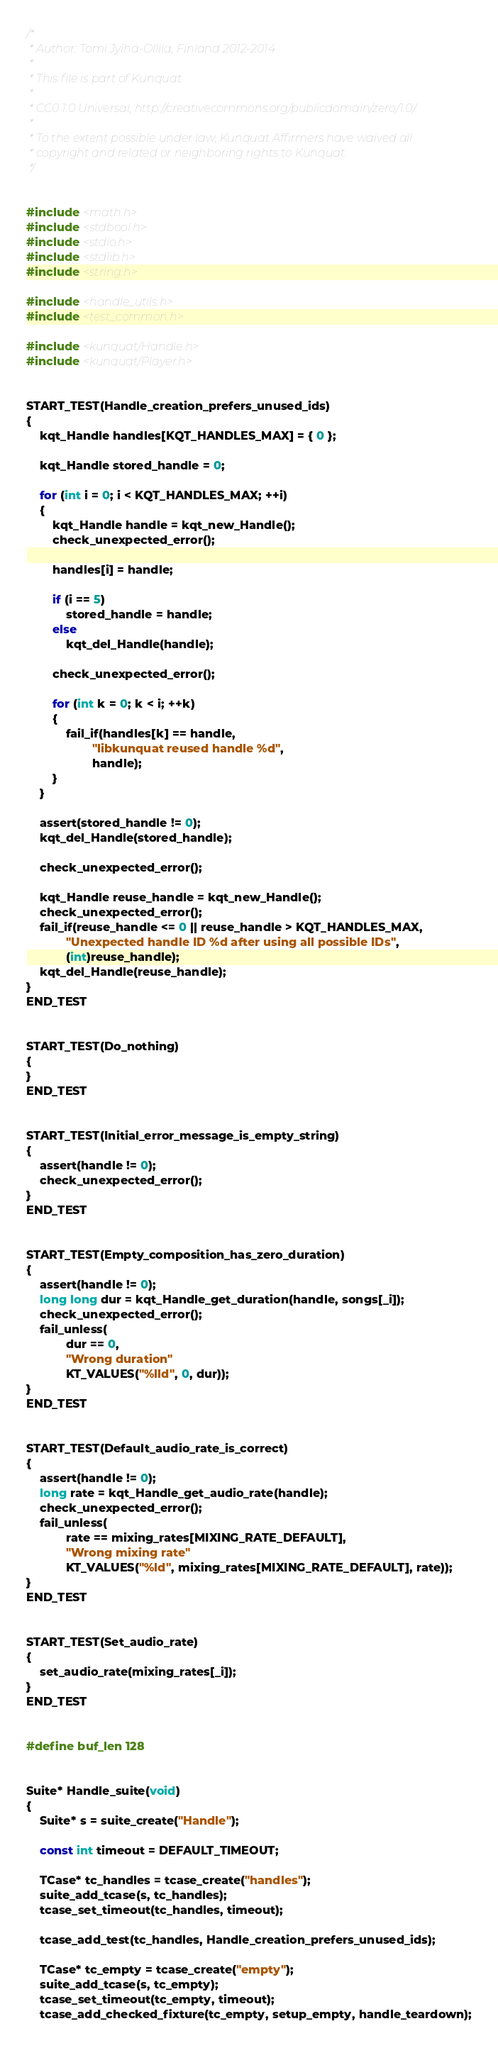Convert code to text. <code><loc_0><loc_0><loc_500><loc_500><_C_>

/*
 * Author: Tomi Jylhä-Ollila, Finland 2012-2014
 *
 * This file is part of Kunquat.
 *
 * CC0 1.0 Universal, http://creativecommons.org/publicdomain/zero/1.0/
 *
 * To the extent possible under law, Kunquat Affirmers have waived all
 * copyright and related or neighboring rights to Kunquat.
 */


#include <math.h>
#include <stdbool.h>
#include <stdio.h>
#include <stdlib.h>
#include <string.h>

#include <handle_utils.h>
#include <test_common.h>

#include <kunquat/Handle.h>
#include <kunquat/Player.h>


START_TEST(Handle_creation_prefers_unused_ids)
{
    kqt_Handle handles[KQT_HANDLES_MAX] = { 0 };

    kqt_Handle stored_handle = 0;

    for (int i = 0; i < KQT_HANDLES_MAX; ++i)
    {
        kqt_Handle handle = kqt_new_Handle();
        check_unexpected_error();

        handles[i] = handle;

        if (i == 5)
            stored_handle = handle;
        else
            kqt_del_Handle(handle);

        check_unexpected_error();

        for (int k = 0; k < i; ++k)
        {
            fail_if(handles[k] == handle,
                    "libkunquat reused handle %d",
                    handle);
        }
    }

    assert(stored_handle != 0);
    kqt_del_Handle(stored_handle);

    check_unexpected_error();

    kqt_Handle reuse_handle = kqt_new_Handle();
    check_unexpected_error();
    fail_if(reuse_handle <= 0 || reuse_handle > KQT_HANDLES_MAX,
            "Unexpected handle ID %d after using all possible IDs",
            (int)reuse_handle);
    kqt_del_Handle(reuse_handle);
}
END_TEST


START_TEST(Do_nothing)
{
}
END_TEST


START_TEST(Initial_error_message_is_empty_string)
{
    assert(handle != 0);
    check_unexpected_error();
}
END_TEST


START_TEST(Empty_composition_has_zero_duration)
{
    assert(handle != 0);
    long long dur = kqt_Handle_get_duration(handle, songs[_i]);
    check_unexpected_error();
    fail_unless(
            dur == 0,
            "Wrong duration"
            KT_VALUES("%lld", 0, dur));
}
END_TEST


START_TEST(Default_audio_rate_is_correct)
{
    assert(handle != 0);
    long rate = kqt_Handle_get_audio_rate(handle);
    check_unexpected_error();
    fail_unless(
            rate == mixing_rates[MIXING_RATE_DEFAULT],
            "Wrong mixing rate"
            KT_VALUES("%ld", mixing_rates[MIXING_RATE_DEFAULT], rate));
}
END_TEST


START_TEST(Set_audio_rate)
{
    set_audio_rate(mixing_rates[_i]);
}
END_TEST


#define buf_len 128


Suite* Handle_suite(void)
{
    Suite* s = suite_create("Handle");

    const int timeout = DEFAULT_TIMEOUT;

    TCase* tc_handles = tcase_create("handles");
    suite_add_tcase(s, tc_handles);
    tcase_set_timeout(tc_handles, timeout);

    tcase_add_test(tc_handles, Handle_creation_prefers_unused_ids);

    TCase* tc_empty = tcase_create("empty");
    suite_add_tcase(s, tc_empty);
    tcase_set_timeout(tc_empty, timeout);
    tcase_add_checked_fixture(tc_empty, setup_empty, handle_teardown);
</code> 